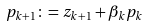Convert formula to latex. <formula><loc_0><loc_0><loc_500><loc_500>p _ { k + 1 } \colon = z _ { k + 1 } + \beta _ { k } p _ { k }</formula> 